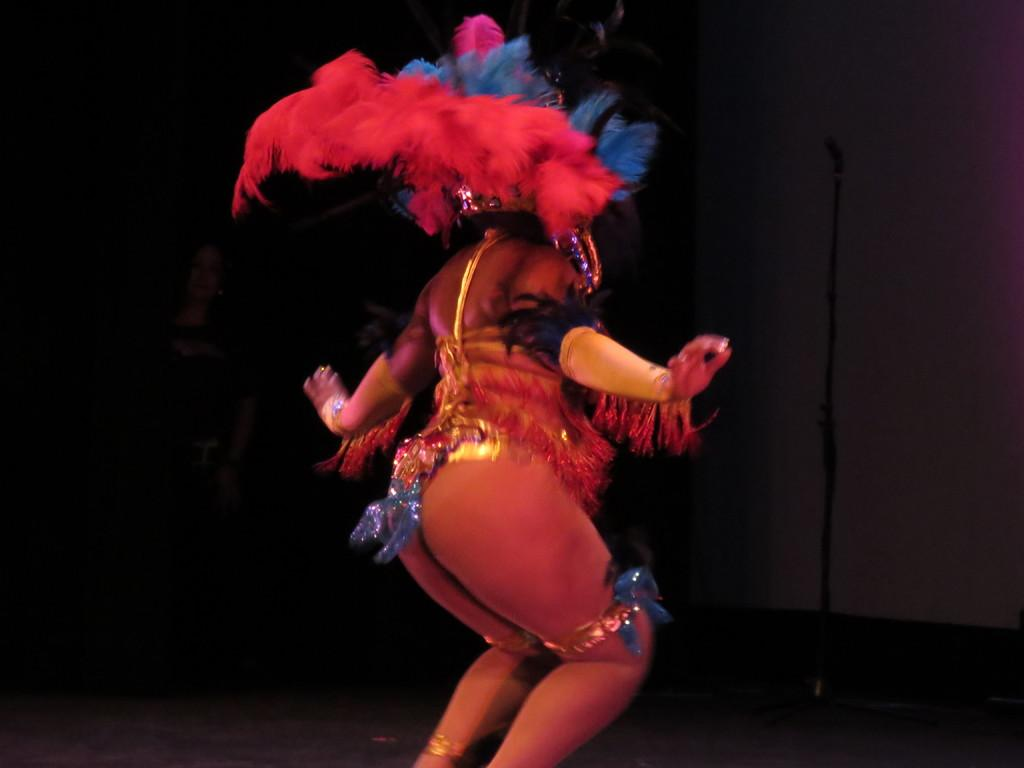Who is the main subject in the image? There is a woman in the image. What is the woman doing in the image? The woman is dancing. What object is present in the image that might be related to the woman's activity? There is a microphone in the image. What type of goose can be seen singing into the microphone in the image? There is no goose present in the image, and the woman is the one dancing and presumably using the microphone. 